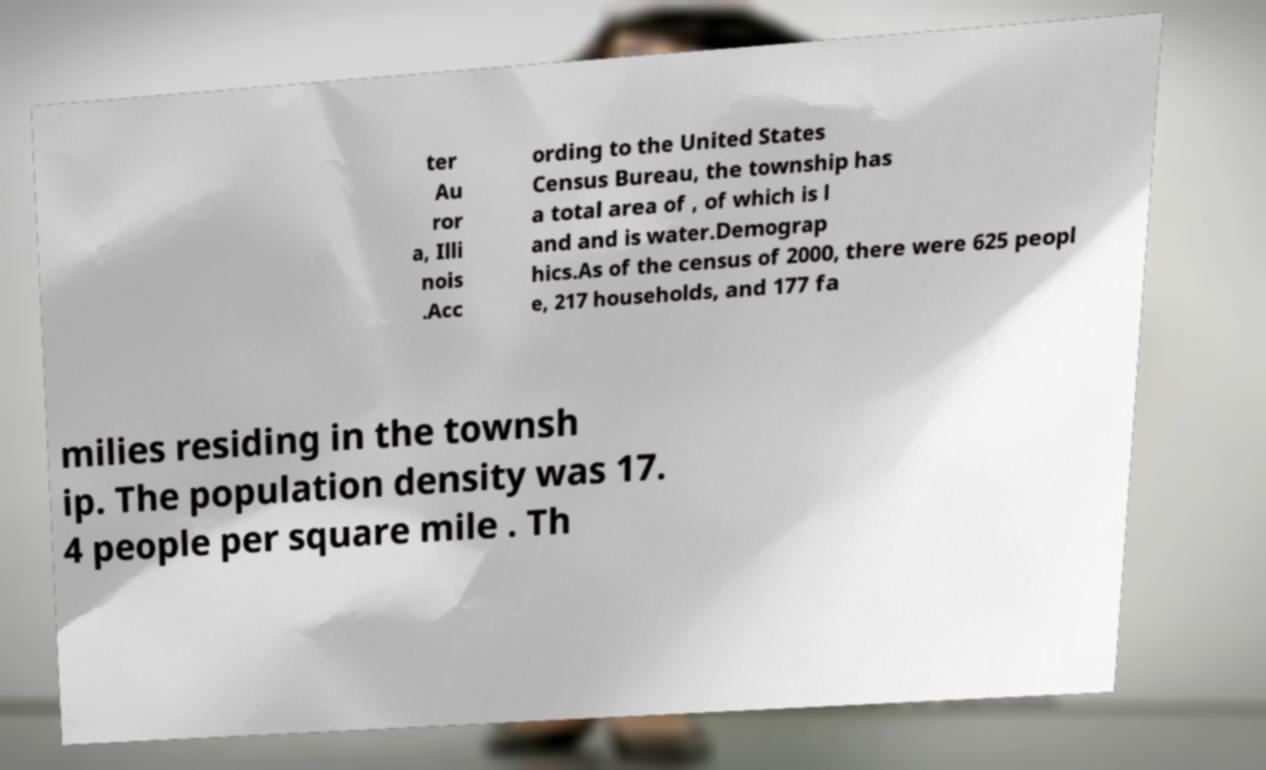I need the written content from this picture converted into text. Can you do that? ter Au ror a, Illi nois .Acc ording to the United States Census Bureau, the township has a total area of , of which is l and and is water.Demograp hics.As of the census of 2000, there were 625 peopl e, 217 households, and 177 fa milies residing in the townsh ip. The population density was 17. 4 people per square mile . Th 